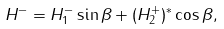Convert formula to latex. <formula><loc_0><loc_0><loc_500><loc_500>H ^ { - } = H _ { 1 } ^ { - } \sin \beta + ( H _ { 2 } ^ { + } ) ^ { * } \cos \beta ,</formula> 